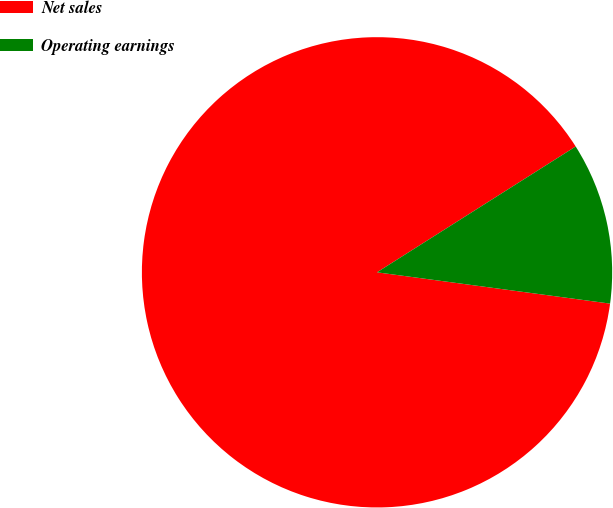Convert chart to OTSL. <chart><loc_0><loc_0><loc_500><loc_500><pie_chart><fcel>Net sales<fcel>Operating earnings<nl><fcel>88.89%<fcel>11.11%<nl></chart> 